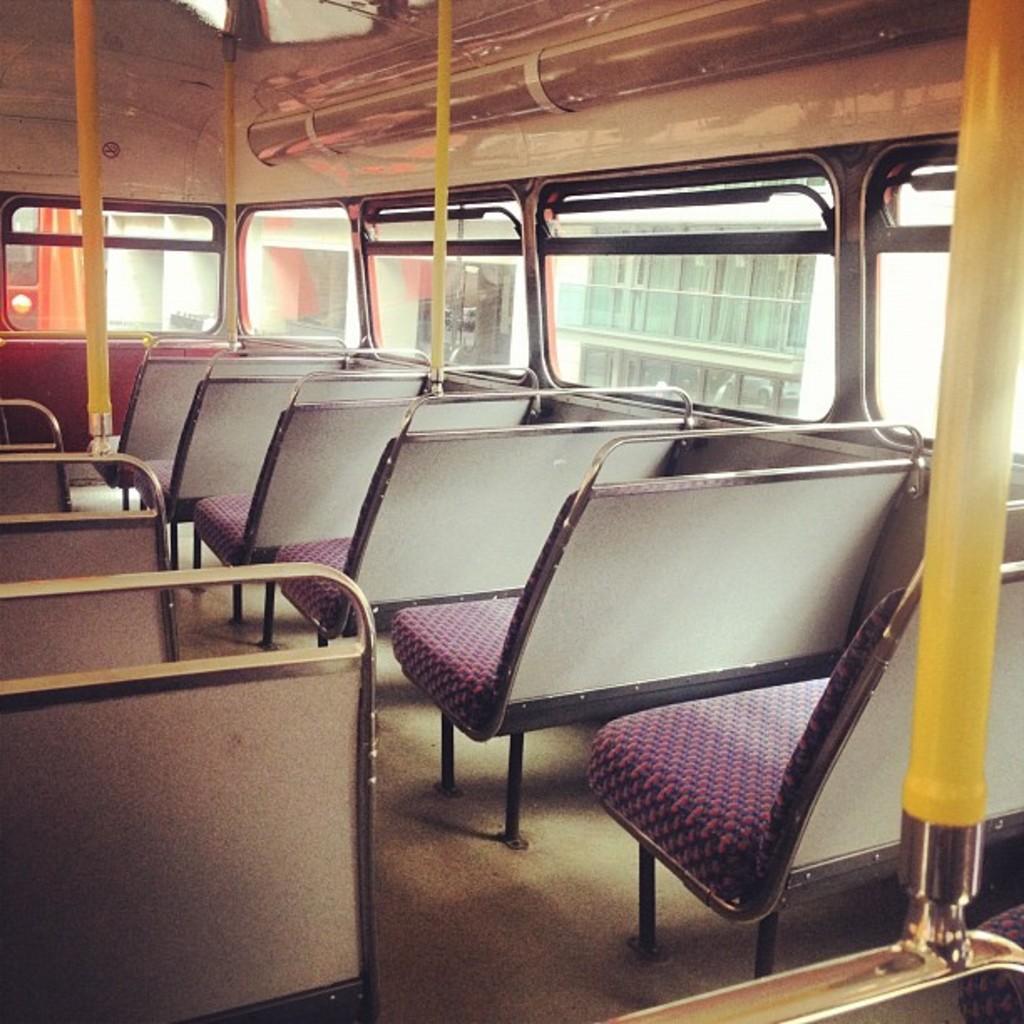Could you give a brief overview of what you see in this image? The picture is taken inside a bus. There are many seats inside the bus. Through the glass windows we can see outside there is building. 